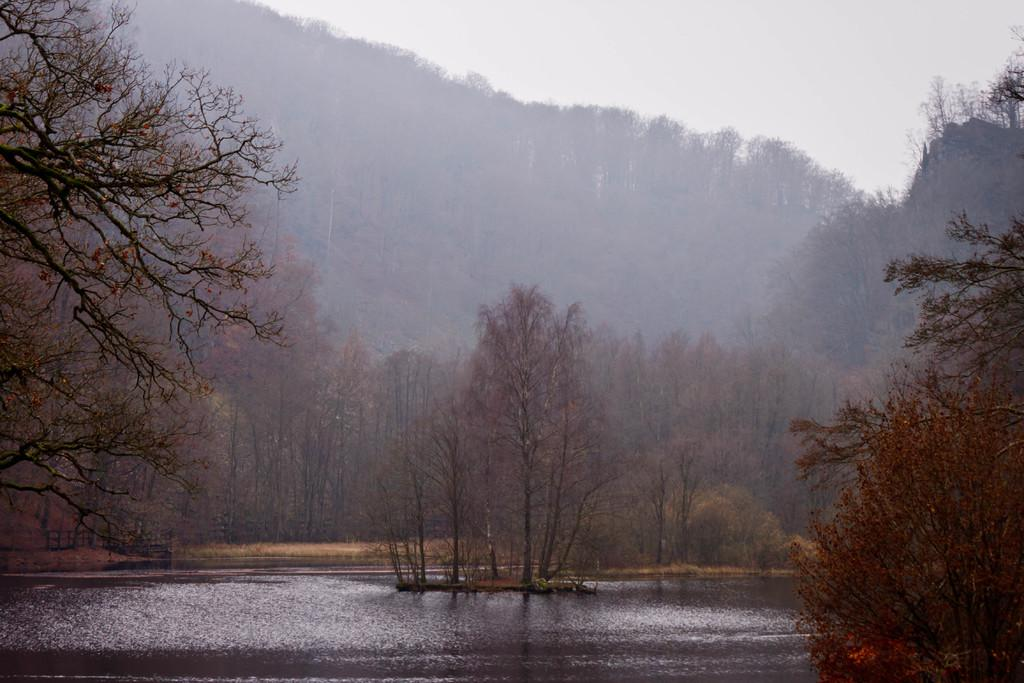What type of vegetation is present in the image? There is a group of trees in the image. What can be seen behind the trees? There are hills visible behind the trees. What is visible at the top of the image? The sky is visible at the top of the image. What is visible at the bottom of the image? There is water visible at the bottom of the image. What letter is hidden in the dirt behind the trees in the image? There is no letter hidden in the dirt behind the trees in the image, as the facts provided do not mention any letters or dirt. 